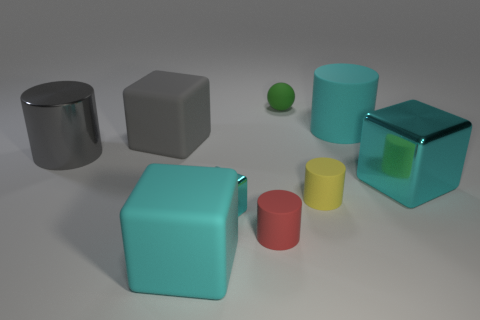How many cyan cubes must be subtracted to get 1 cyan cubes? 2 Subtract all purple spheres. How many cyan cubes are left? 3 Subtract 1 cubes. How many cubes are left? 3 Subtract all yellow cylinders. How many cylinders are left? 3 Subtract all large rubber cylinders. How many cylinders are left? 3 Subtract all red blocks. Subtract all purple spheres. How many blocks are left? 4 Add 1 cyan objects. How many objects exist? 10 Subtract all blocks. How many objects are left? 5 Add 2 tiny spheres. How many tiny spheres exist? 3 Subtract 0 gray balls. How many objects are left? 9 